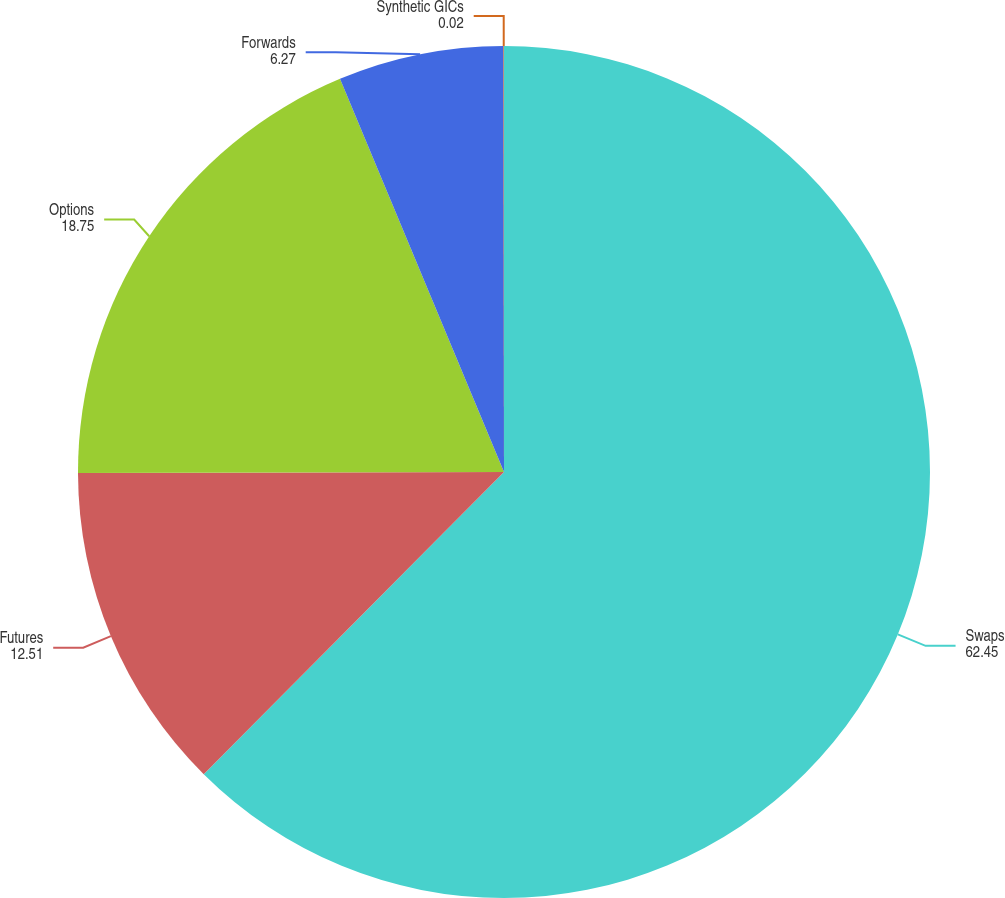<chart> <loc_0><loc_0><loc_500><loc_500><pie_chart><fcel>Swaps<fcel>Futures<fcel>Options<fcel>Forwards<fcel>Synthetic GICs<nl><fcel>62.45%<fcel>12.51%<fcel>18.75%<fcel>6.27%<fcel>0.02%<nl></chart> 